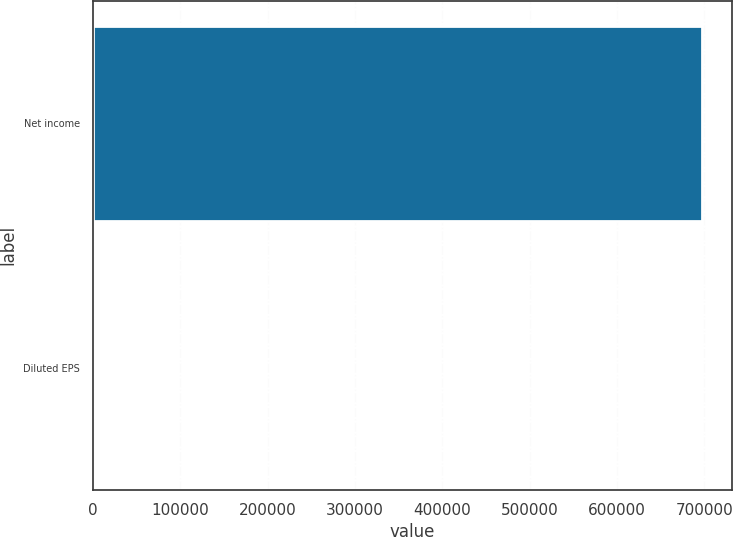Convert chart. <chart><loc_0><loc_0><loc_500><loc_500><bar_chart><fcel>Net income<fcel>Diluted EPS<nl><fcel>696878<fcel>2.2<nl></chart> 